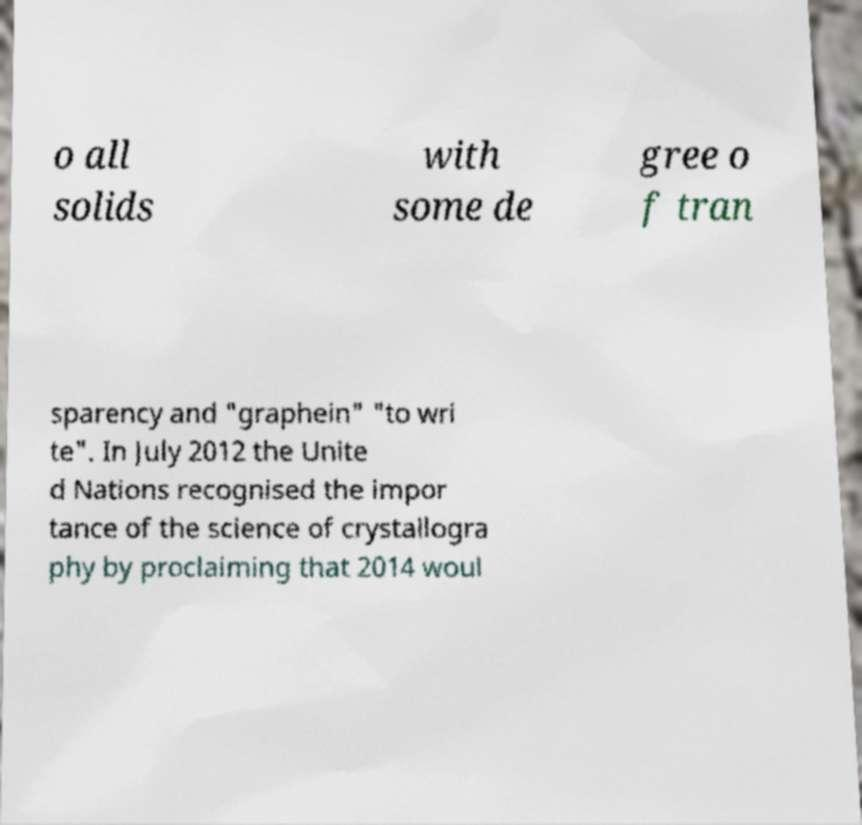Please read and relay the text visible in this image. What does it say? o all solids with some de gree o f tran sparency and "graphein" "to wri te". In July 2012 the Unite d Nations recognised the impor tance of the science of crystallogra phy by proclaiming that 2014 woul 